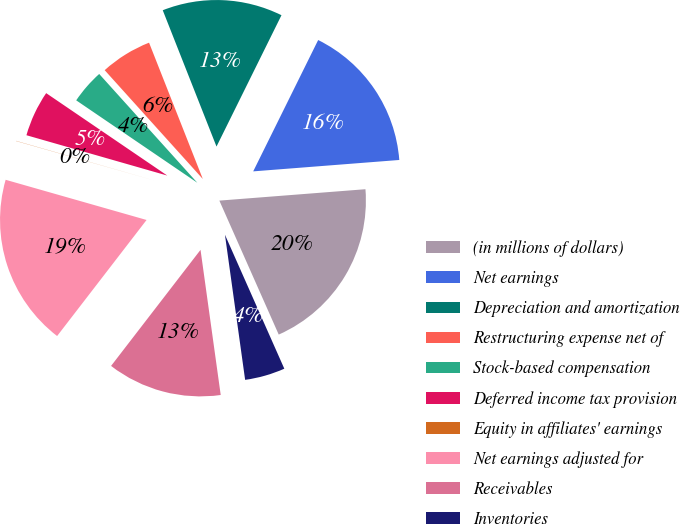<chart> <loc_0><loc_0><loc_500><loc_500><pie_chart><fcel>(in millions of dollars)<fcel>Net earnings<fcel>Depreciation and amortization<fcel>Restructuring expense net of<fcel>Stock-based compensation<fcel>Deferred income tax provision<fcel>Equity in affiliates' earnings<fcel>Net earnings adjusted for<fcel>Receivables<fcel>Inventories<nl><fcel>19.6%<fcel>16.45%<fcel>13.29%<fcel>5.7%<fcel>3.81%<fcel>5.07%<fcel>0.02%<fcel>18.97%<fcel>12.65%<fcel>4.44%<nl></chart> 